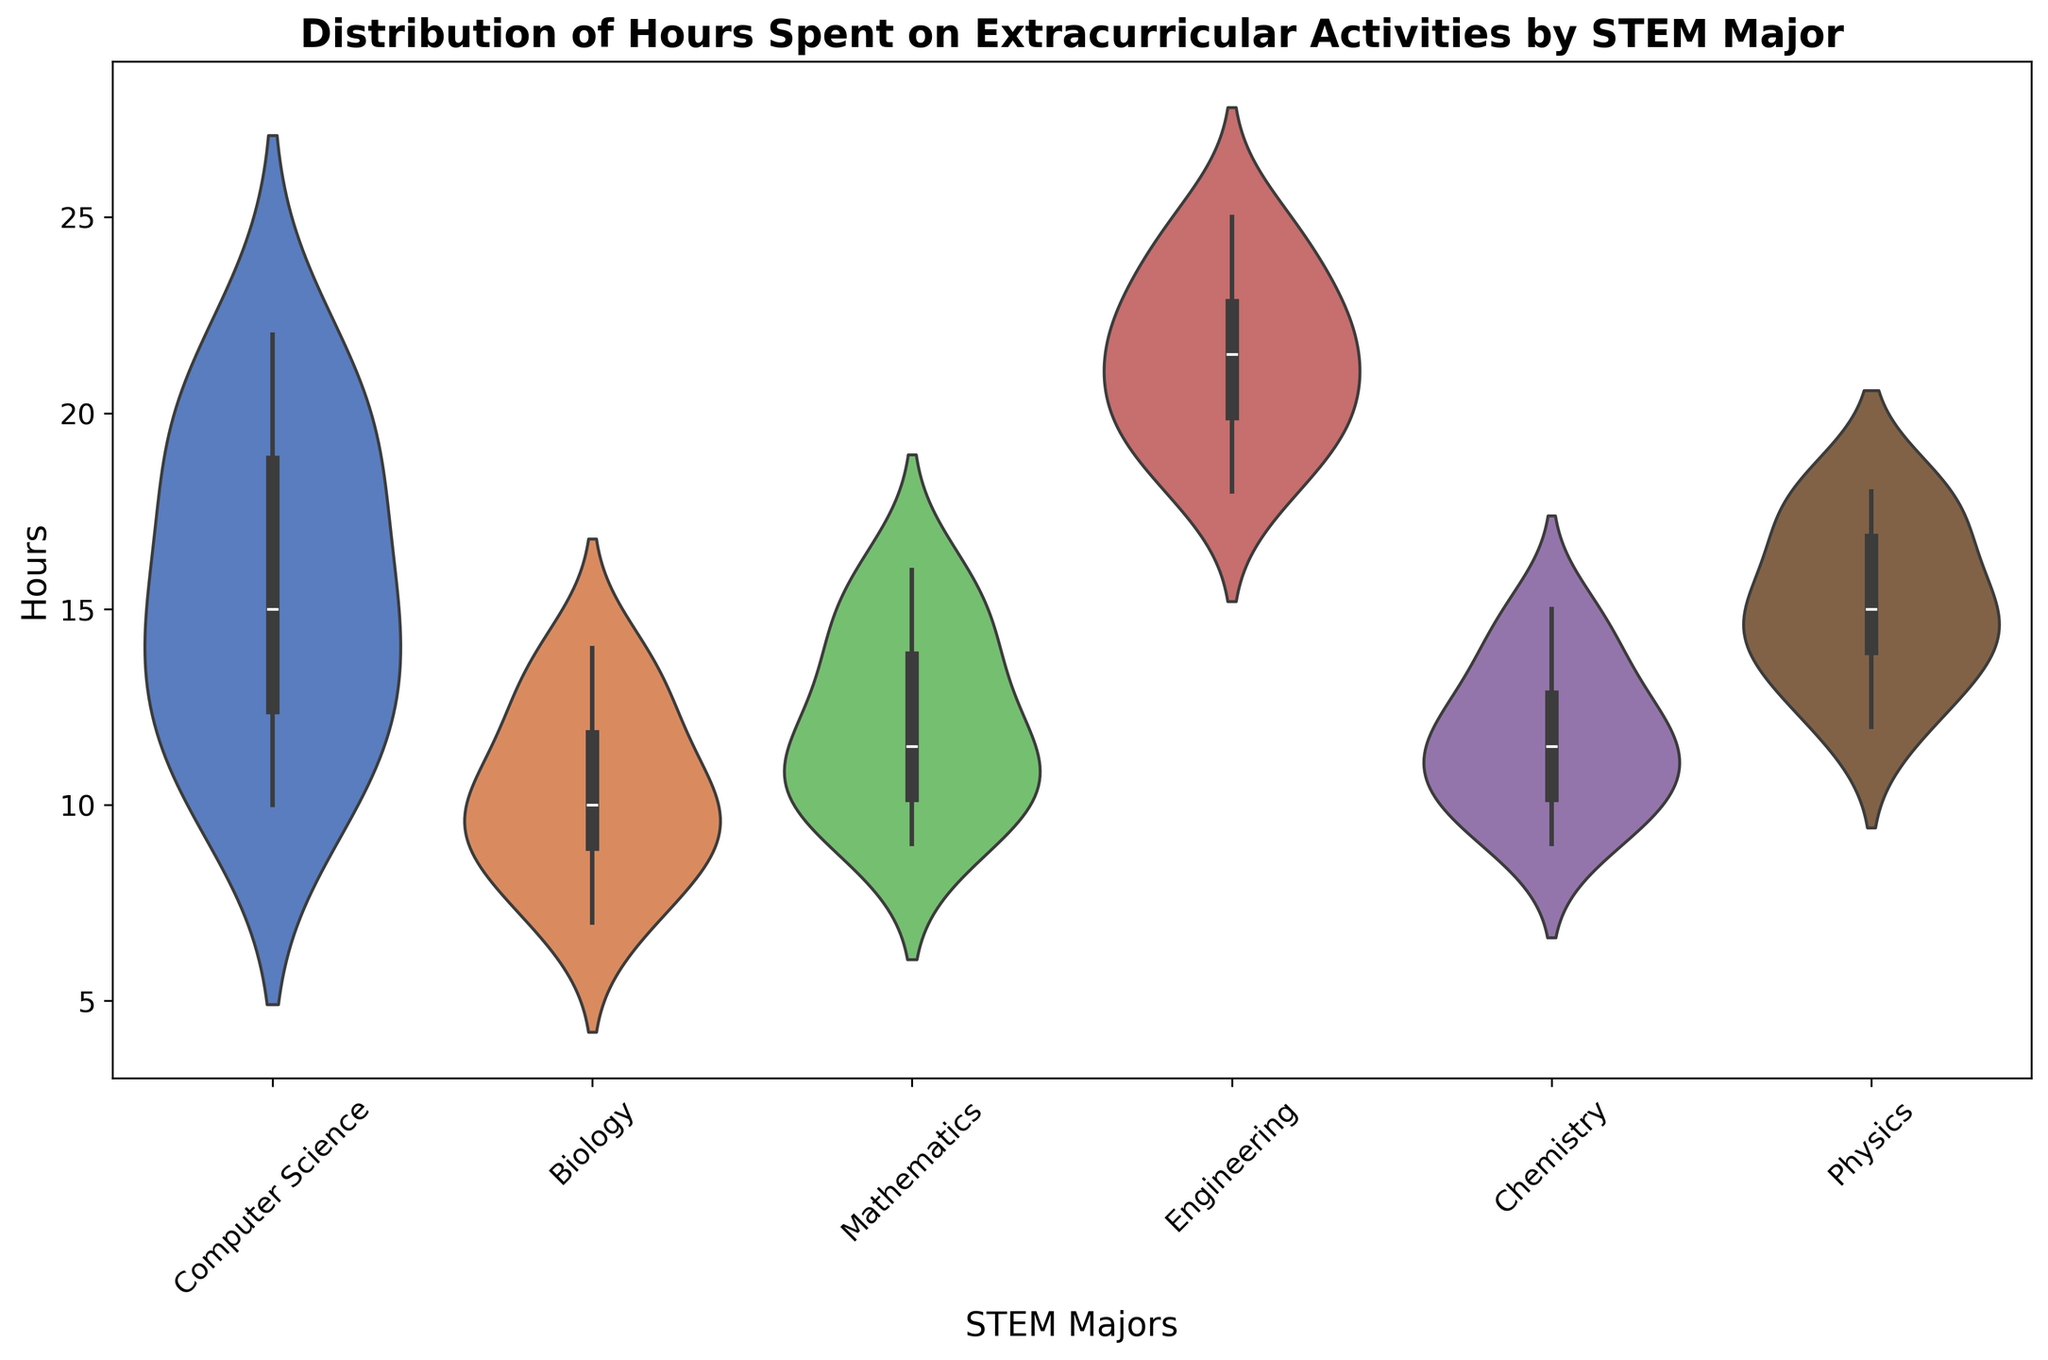Which STEM major shows the highest median number of hours spent on extracurricular activities? The median is represented by the line within the violin plot for each major. Visually, the median for Engineering is the highest among all the majors
Answer: Engineering Which STEM major shows the widest distribution of hours spent on extracurricular activities? The width of the violin plot represents the distribution. Engineering shows the widest distribution as its violin plot is the broadest along the y-axis
Answer: Engineering What is the approximate range of hours spent on extracurricular activities for Computer Science students? The range can be observed from the lowest to the highest point in the violin plot. For Computer Science, it roughly ranges from 10 to 22 hours
Answer: 10 to 22 hours Compare the medians of hours spent on extracurricular activities between Biology and Engineering students. Which is higher? The medians are represented by the lines inside the violin plots. Visually, Engineering has a higher median compared to Biology
Answer: Engineering Which STEM major has the least variability in terms of hours spent on extracurricular activities? Variability can be inferred from the narrowness of the plot. Physics appears to have the least variability because the violin plot is relatively narrow compared to others
Answer: Physics What is the difference in median hours spent on extracurricular activities between Mathematics and Chemistry students? The median lines inside the violin plots show that Mathematics and Chemistry have fairly similar median hours. To find the exact difference visually might be zero or minimal
Answer: Approximately 0 hours How do the distributions of hours spent on extracurricular activities for Physics and Chemistry compare visually? Both plots are fairly similar in terms of shape. However, Physics has a slightly wider range and appears shifted upward compared to Chemistry
Answer: Physics is slightly higher Is the distribution of hours for Biology students symmetrical? The symmetry can be observed by looking at the shape of the violin plot. The distribution for Biology is relatively symmetrical as both sides of the violin plot mirror each other closely
Answer: Yes What is the most common number of extracurricular hours for Engineering students? The most common hours can be observed at the widest part of the violin plot. For Engineering, the widest part is around 22 hours
Answer: About 22 hours Compare the overall spread of hours between Mathematics and Physics majors. Which one has a wider spread? Spread is determined by the range from the lowest to highest point of the plot. Mathematics has a wider spread visually extending more on both ends
Answer: Mathematics 